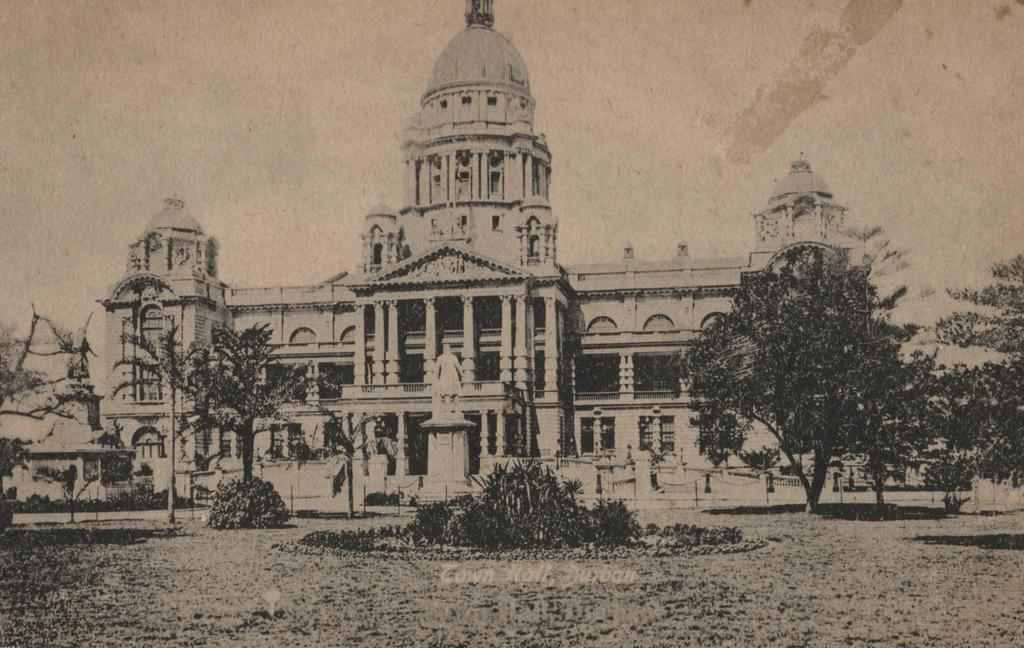What is the main subject in the middle of the image? There is a building, trees, a statue, and bushes in the middle of the image. Can you describe the statue in the image? There is a statue in the middle of the image. What type of vegetation can be seen in the middle of the image? There are trees and bushes in the middle of the image. What causes the statue to cough in the image? There is no indication in the image that the statue is coughing or capable of coughing, as it is an inanimate object. 